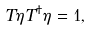Convert formula to latex. <formula><loc_0><loc_0><loc_500><loc_500>T \eta T ^ { \dagger } \eta = 1 ,</formula> 